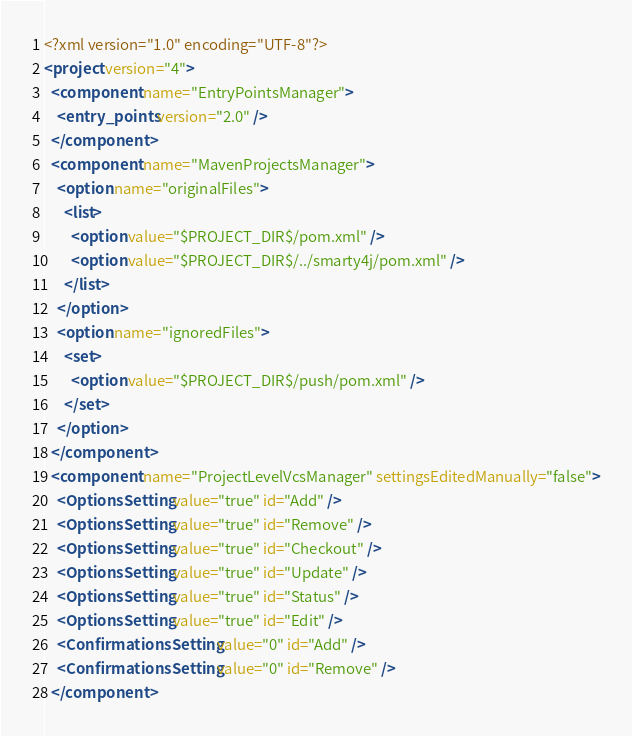Convert code to text. <code><loc_0><loc_0><loc_500><loc_500><_XML_><?xml version="1.0" encoding="UTF-8"?>
<project version="4">
  <component name="EntryPointsManager">
    <entry_points version="2.0" />
  </component>
  <component name="MavenProjectsManager">
    <option name="originalFiles">
      <list>
        <option value="$PROJECT_DIR$/pom.xml" />
        <option value="$PROJECT_DIR$/../smarty4j/pom.xml" />
      </list>
    </option>
    <option name="ignoredFiles">
      <set>
        <option value="$PROJECT_DIR$/push/pom.xml" />
      </set>
    </option>
  </component>
  <component name="ProjectLevelVcsManager" settingsEditedManually="false">
    <OptionsSetting value="true" id="Add" />
    <OptionsSetting value="true" id="Remove" />
    <OptionsSetting value="true" id="Checkout" />
    <OptionsSetting value="true" id="Update" />
    <OptionsSetting value="true" id="Status" />
    <OptionsSetting value="true" id="Edit" />
    <ConfirmationsSetting value="0" id="Add" />
    <ConfirmationsSetting value="0" id="Remove" />
  </component></code> 